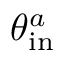<formula> <loc_0><loc_0><loc_500><loc_500>\theta _ { i n } ^ { a }</formula> 